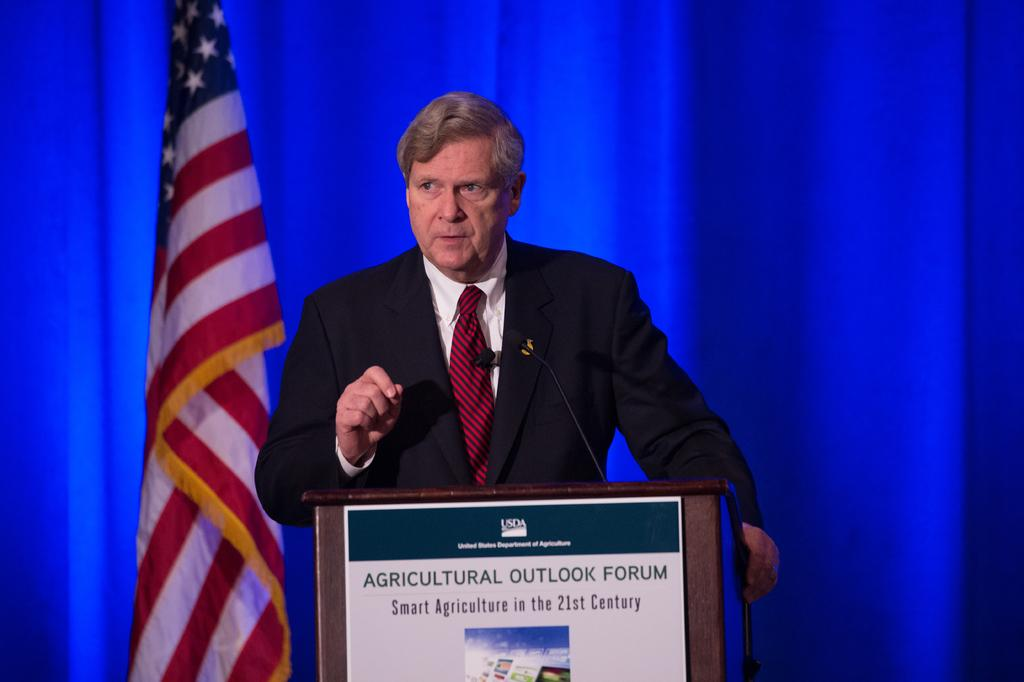What is the man in the image doing? The man is standing in front of a podium. What is on the podium? The podium has a mic and a board on it. What can be seen in the background of the image? There is a curtain and a flag in the background of the image. What type of property is being discussed in the image? There is no discussion of property in the image; it simply shows a man standing in front of a podium with a mic and a board on it. Is there any dirt or waste visible in the image? No, there is no dirt or waste visible in the image. 